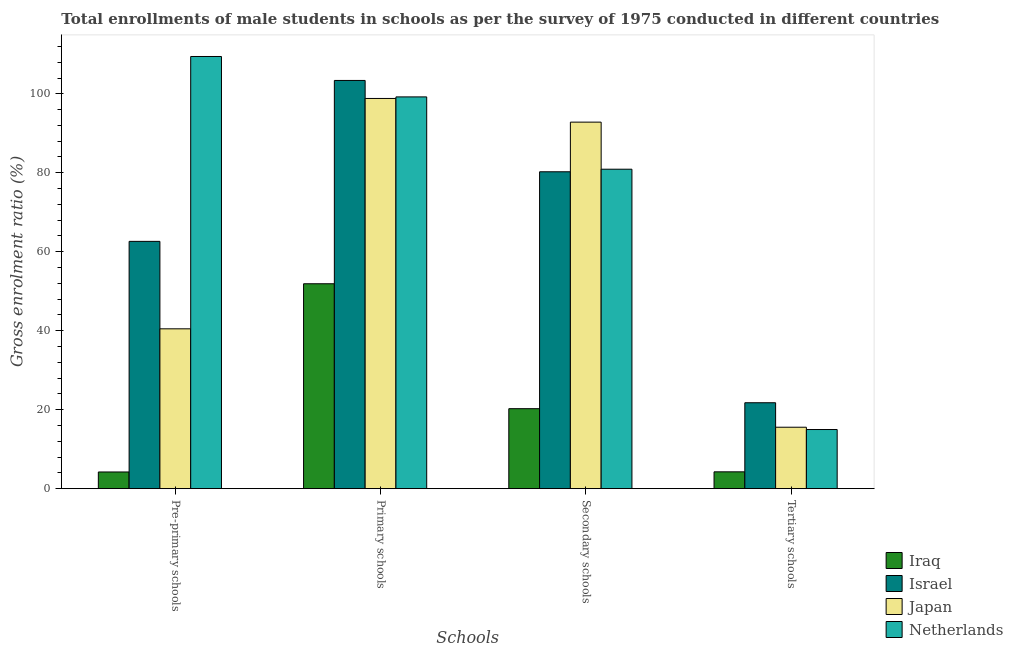Are the number of bars per tick equal to the number of legend labels?
Offer a terse response. Yes. Are the number of bars on each tick of the X-axis equal?
Offer a terse response. Yes. How many bars are there on the 2nd tick from the right?
Your response must be concise. 4. What is the label of the 2nd group of bars from the left?
Make the answer very short. Primary schools. What is the gross enrolment ratio(male) in tertiary schools in Israel?
Make the answer very short. 21.76. Across all countries, what is the maximum gross enrolment ratio(male) in pre-primary schools?
Your response must be concise. 109.46. Across all countries, what is the minimum gross enrolment ratio(male) in pre-primary schools?
Keep it short and to the point. 4.23. In which country was the gross enrolment ratio(male) in pre-primary schools minimum?
Keep it short and to the point. Iraq. What is the total gross enrolment ratio(male) in secondary schools in the graph?
Offer a very short reply. 274.25. What is the difference between the gross enrolment ratio(male) in secondary schools in Iraq and that in Israel?
Keep it short and to the point. -60. What is the difference between the gross enrolment ratio(male) in secondary schools in Israel and the gross enrolment ratio(male) in primary schools in Iraq?
Your answer should be very brief. 28.36. What is the average gross enrolment ratio(male) in tertiary schools per country?
Make the answer very short. 14.14. What is the difference between the gross enrolment ratio(male) in pre-primary schools and gross enrolment ratio(male) in tertiary schools in Israel?
Your response must be concise. 40.87. What is the ratio of the gross enrolment ratio(male) in tertiary schools in Japan to that in Iraq?
Your response must be concise. 3.65. Is the gross enrolment ratio(male) in secondary schools in Japan less than that in Netherlands?
Offer a very short reply. No. What is the difference between the highest and the second highest gross enrolment ratio(male) in pre-primary schools?
Provide a short and direct response. 46.82. What is the difference between the highest and the lowest gross enrolment ratio(male) in primary schools?
Offer a very short reply. 51.49. Is the sum of the gross enrolment ratio(male) in secondary schools in Netherlands and Iraq greater than the maximum gross enrolment ratio(male) in primary schools across all countries?
Your answer should be very brief. No. Where does the legend appear in the graph?
Offer a terse response. Bottom right. How are the legend labels stacked?
Offer a terse response. Vertical. What is the title of the graph?
Your answer should be very brief. Total enrollments of male students in schools as per the survey of 1975 conducted in different countries. What is the label or title of the X-axis?
Your answer should be very brief. Schools. What is the label or title of the Y-axis?
Offer a terse response. Gross enrolment ratio (%). What is the Gross enrolment ratio (%) of Iraq in Pre-primary schools?
Provide a short and direct response. 4.23. What is the Gross enrolment ratio (%) in Israel in Pre-primary schools?
Provide a succinct answer. 62.63. What is the Gross enrolment ratio (%) of Japan in Pre-primary schools?
Provide a succinct answer. 40.48. What is the Gross enrolment ratio (%) in Netherlands in Pre-primary schools?
Your answer should be very brief. 109.46. What is the Gross enrolment ratio (%) of Iraq in Primary schools?
Provide a succinct answer. 51.89. What is the Gross enrolment ratio (%) in Israel in Primary schools?
Make the answer very short. 103.39. What is the Gross enrolment ratio (%) in Japan in Primary schools?
Ensure brevity in your answer.  98.82. What is the Gross enrolment ratio (%) in Netherlands in Primary schools?
Your answer should be very brief. 99.22. What is the Gross enrolment ratio (%) of Iraq in Secondary schools?
Give a very brief answer. 20.26. What is the Gross enrolment ratio (%) of Israel in Secondary schools?
Ensure brevity in your answer.  80.26. What is the Gross enrolment ratio (%) of Japan in Secondary schools?
Offer a very short reply. 92.83. What is the Gross enrolment ratio (%) of Netherlands in Secondary schools?
Keep it short and to the point. 80.91. What is the Gross enrolment ratio (%) of Iraq in Tertiary schools?
Offer a terse response. 4.27. What is the Gross enrolment ratio (%) of Israel in Tertiary schools?
Make the answer very short. 21.76. What is the Gross enrolment ratio (%) of Japan in Tertiary schools?
Ensure brevity in your answer.  15.56. What is the Gross enrolment ratio (%) in Netherlands in Tertiary schools?
Make the answer very short. 14.98. Across all Schools, what is the maximum Gross enrolment ratio (%) in Iraq?
Your answer should be very brief. 51.89. Across all Schools, what is the maximum Gross enrolment ratio (%) in Israel?
Provide a succinct answer. 103.39. Across all Schools, what is the maximum Gross enrolment ratio (%) of Japan?
Provide a succinct answer. 98.82. Across all Schools, what is the maximum Gross enrolment ratio (%) of Netherlands?
Give a very brief answer. 109.46. Across all Schools, what is the minimum Gross enrolment ratio (%) of Iraq?
Provide a succinct answer. 4.23. Across all Schools, what is the minimum Gross enrolment ratio (%) of Israel?
Your response must be concise. 21.76. Across all Schools, what is the minimum Gross enrolment ratio (%) of Japan?
Offer a terse response. 15.56. Across all Schools, what is the minimum Gross enrolment ratio (%) in Netherlands?
Provide a short and direct response. 14.98. What is the total Gross enrolment ratio (%) in Iraq in the graph?
Make the answer very short. 80.65. What is the total Gross enrolment ratio (%) in Israel in the graph?
Your response must be concise. 268.04. What is the total Gross enrolment ratio (%) in Japan in the graph?
Make the answer very short. 247.7. What is the total Gross enrolment ratio (%) in Netherlands in the graph?
Make the answer very short. 304.56. What is the difference between the Gross enrolment ratio (%) of Iraq in Pre-primary schools and that in Primary schools?
Your answer should be very brief. -47.66. What is the difference between the Gross enrolment ratio (%) of Israel in Pre-primary schools and that in Primary schools?
Your response must be concise. -40.75. What is the difference between the Gross enrolment ratio (%) of Japan in Pre-primary schools and that in Primary schools?
Provide a succinct answer. -58.34. What is the difference between the Gross enrolment ratio (%) in Netherlands in Pre-primary schools and that in Primary schools?
Provide a succinct answer. 10.24. What is the difference between the Gross enrolment ratio (%) of Iraq in Pre-primary schools and that in Secondary schools?
Ensure brevity in your answer.  -16.03. What is the difference between the Gross enrolment ratio (%) in Israel in Pre-primary schools and that in Secondary schools?
Ensure brevity in your answer.  -17.62. What is the difference between the Gross enrolment ratio (%) in Japan in Pre-primary schools and that in Secondary schools?
Offer a very short reply. -52.34. What is the difference between the Gross enrolment ratio (%) in Netherlands in Pre-primary schools and that in Secondary schools?
Your answer should be compact. 28.55. What is the difference between the Gross enrolment ratio (%) in Iraq in Pre-primary schools and that in Tertiary schools?
Ensure brevity in your answer.  -0.04. What is the difference between the Gross enrolment ratio (%) in Israel in Pre-primary schools and that in Tertiary schools?
Offer a terse response. 40.87. What is the difference between the Gross enrolment ratio (%) of Japan in Pre-primary schools and that in Tertiary schools?
Offer a very short reply. 24.92. What is the difference between the Gross enrolment ratio (%) in Netherlands in Pre-primary schools and that in Tertiary schools?
Keep it short and to the point. 94.47. What is the difference between the Gross enrolment ratio (%) of Iraq in Primary schools and that in Secondary schools?
Provide a succinct answer. 31.64. What is the difference between the Gross enrolment ratio (%) in Israel in Primary schools and that in Secondary schools?
Give a very brief answer. 23.13. What is the difference between the Gross enrolment ratio (%) of Japan in Primary schools and that in Secondary schools?
Offer a terse response. 6. What is the difference between the Gross enrolment ratio (%) of Netherlands in Primary schools and that in Secondary schools?
Offer a very short reply. 18.31. What is the difference between the Gross enrolment ratio (%) in Iraq in Primary schools and that in Tertiary schools?
Your answer should be compact. 47.63. What is the difference between the Gross enrolment ratio (%) in Israel in Primary schools and that in Tertiary schools?
Your answer should be compact. 81.62. What is the difference between the Gross enrolment ratio (%) of Japan in Primary schools and that in Tertiary schools?
Make the answer very short. 83.26. What is the difference between the Gross enrolment ratio (%) of Netherlands in Primary schools and that in Tertiary schools?
Provide a succinct answer. 84.24. What is the difference between the Gross enrolment ratio (%) in Iraq in Secondary schools and that in Tertiary schools?
Offer a terse response. 15.99. What is the difference between the Gross enrolment ratio (%) of Israel in Secondary schools and that in Tertiary schools?
Provide a short and direct response. 58.49. What is the difference between the Gross enrolment ratio (%) in Japan in Secondary schools and that in Tertiary schools?
Your response must be concise. 77.26. What is the difference between the Gross enrolment ratio (%) of Netherlands in Secondary schools and that in Tertiary schools?
Your answer should be very brief. 65.92. What is the difference between the Gross enrolment ratio (%) in Iraq in Pre-primary schools and the Gross enrolment ratio (%) in Israel in Primary schools?
Provide a short and direct response. -99.16. What is the difference between the Gross enrolment ratio (%) of Iraq in Pre-primary schools and the Gross enrolment ratio (%) of Japan in Primary schools?
Provide a short and direct response. -94.59. What is the difference between the Gross enrolment ratio (%) in Iraq in Pre-primary schools and the Gross enrolment ratio (%) in Netherlands in Primary schools?
Provide a short and direct response. -94.99. What is the difference between the Gross enrolment ratio (%) in Israel in Pre-primary schools and the Gross enrolment ratio (%) in Japan in Primary schools?
Your response must be concise. -36.19. What is the difference between the Gross enrolment ratio (%) in Israel in Pre-primary schools and the Gross enrolment ratio (%) in Netherlands in Primary schools?
Your answer should be very brief. -36.59. What is the difference between the Gross enrolment ratio (%) of Japan in Pre-primary schools and the Gross enrolment ratio (%) of Netherlands in Primary schools?
Your answer should be very brief. -58.74. What is the difference between the Gross enrolment ratio (%) in Iraq in Pre-primary schools and the Gross enrolment ratio (%) in Israel in Secondary schools?
Make the answer very short. -76.03. What is the difference between the Gross enrolment ratio (%) in Iraq in Pre-primary schools and the Gross enrolment ratio (%) in Japan in Secondary schools?
Ensure brevity in your answer.  -88.6. What is the difference between the Gross enrolment ratio (%) in Iraq in Pre-primary schools and the Gross enrolment ratio (%) in Netherlands in Secondary schools?
Give a very brief answer. -76.68. What is the difference between the Gross enrolment ratio (%) of Israel in Pre-primary schools and the Gross enrolment ratio (%) of Japan in Secondary schools?
Make the answer very short. -30.19. What is the difference between the Gross enrolment ratio (%) in Israel in Pre-primary schools and the Gross enrolment ratio (%) in Netherlands in Secondary schools?
Make the answer very short. -18.27. What is the difference between the Gross enrolment ratio (%) in Japan in Pre-primary schools and the Gross enrolment ratio (%) in Netherlands in Secondary schools?
Provide a short and direct response. -40.42. What is the difference between the Gross enrolment ratio (%) in Iraq in Pre-primary schools and the Gross enrolment ratio (%) in Israel in Tertiary schools?
Your answer should be compact. -17.53. What is the difference between the Gross enrolment ratio (%) of Iraq in Pre-primary schools and the Gross enrolment ratio (%) of Japan in Tertiary schools?
Your answer should be compact. -11.33. What is the difference between the Gross enrolment ratio (%) of Iraq in Pre-primary schools and the Gross enrolment ratio (%) of Netherlands in Tertiary schools?
Your answer should be very brief. -10.75. What is the difference between the Gross enrolment ratio (%) of Israel in Pre-primary schools and the Gross enrolment ratio (%) of Japan in Tertiary schools?
Your answer should be compact. 47.07. What is the difference between the Gross enrolment ratio (%) in Israel in Pre-primary schools and the Gross enrolment ratio (%) in Netherlands in Tertiary schools?
Your answer should be compact. 47.65. What is the difference between the Gross enrolment ratio (%) of Japan in Pre-primary schools and the Gross enrolment ratio (%) of Netherlands in Tertiary schools?
Your answer should be very brief. 25.5. What is the difference between the Gross enrolment ratio (%) in Iraq in Primary schools and the Gross enrolment ratio (%) in Israel in Secondary schools?
Ensure brevity in your answer.  -28.36. What is the difference between the Gross enrolment ratio (%) in Iraq in Primary schools and the Gross enrolment ratio (%) in Japan in Secondary schools?
Keep it short and to the point. -40.93. What is the difference between the Gross enrolment ratio (%) of Iraq in Primary schools and the Gross enrolment ratio (%) of Netherlands in Secondary schools?
Offer a very short reply. -29.01. What is the difference between the Gross enrolment ratio (%) of Israel in Primary schools and the Gross enrolment ratio (%) of Japan in Secondary schools?
Keep it short and to the point. 10.56. What is the difference between the Gross enrolment ratio (%) of Israel in Primary schools and the Gross enrolment ratio (%) of Netherlands in Secondary schools?
Offer a terse response. 22.48. What is the difference between the Gross enrolment ratio (%) of Japan in Primary schools and the Gross enrolment ratio (%) of Netherlands in Secondary schools?
Your response must be concise. 17.92. What is the difference between the Gross enrolment ratio (%) of Iraq in Primary schools and the Gross enrolment ratio (%) of Israel in Tertiary schools?
Give a very brief answer. 30.13. What is the difference between the Gross enrolment ratio (%) of Iraq in Primary schools and the Gross enrolment ratio (%) of Japan in Tertiary schools?
Your answer should be very brief. 36.33. What is the difference between the Gross enrolment ratio (%) of Iraq in Primary schools and the Gross enrolment ratio (%) of Netherlands in Tertiary schools?
Keep it short and to the point. 36.91. What is the difference between the Gross enrolment ratio (%) in Israel in Primary schools and the Gross enrolment ratio (%) in Japan in Tertiary schools?
Offer a very short reply. 87.82. What is the difference between the Gross enrolment ratio (%) of Israel in Primary schools and the Gross enrolment ratio (%) of Netherlands in Tertiary schools?
Offer a very short reply. 88.41. What is the difference between the Gross enrolment ratio (%) of Japan in Primary schools and the Gross enrolment ratio (%) of Netherlands in Tertiary schools?
Your response must be concise. 83.84. What is the difference between the Gross enrolment ratio (%) in Iraq in Secondary schools and the Gross enrolment ratio (%) in Israel in Tertiary schools?
Your answer should be very brief. -1.5. What is the difference between the Gross enrolment ratio (%) of Iraq in Secondary schools and the Gross enrolment ratio (%) of Japan in Tertiary schools?
Give a very brief answer. 4.7. What is the difference between the Gross enrolment ratio (%) of Iraq in Secondary schools and the Gross enrolment ratio (%) of Netherlands in Tertiary schools?
Provide a short and direct response. 5.28. What is the difference between the Gross enrolment ratio (%) of Israel in Secondary schools and the Gross enrolment ratio (%) of Japan in Tertiary schools?
Offer a very short reply. 64.69. What is the difference between the Gross enrolment ratio (%) in Israel in Secondary schools and the Gross enrolment ratio (%) in Netherlands in Tertiary schools?
Offer a terse response. 65.28. What is the difference between the Gross enrolment ratio (%) in Japan in Secondary schools and the Gross enrolment ratio (%) in Netherlands in Tertiary schools?
Give a very brief answer. 77.85. What is the average Gross enrolment ratio (%) in Iraq per Schools?
Provide a short and direct response. 20.16. What is the average Gross enrolment ratio (%) of Israel per Schools?
Provide a succinct answer. 67.01. What is the average Gross enrolment ratio (%) in Japan per Schools?
Offer a terse response. 61.92. What is the average Gross enrolment ratio (%) of Netherlands per Schools?
Provide a short and direct response. 76.14. What is the difference between the Gross enrolment ratio (%) in Iraq and Gross enrolment ratio (%) in Israel in Pre-primary schools?
Your answer should be very brief. -58.4. What is the difference between the Gross enrolment ratio (%) in Iraq and Gross enrolment ratio (%) in Japan in Pre-primary schools?
Give a very brief answer. -36.25. What is the difference between the Gross enrolment ratio (%) in Iraq and Gross enrolment ratio (%) in Netherlands in Pre-primary schools?
Offer a very short reply. -105.22. What is the difference between the Gross enrolment ratio (%) of Israel and Gross enrolment ratio (%) of Japan in Pre-primary schools?
Give a very brief answer. 22.15. What is the difference between the Gross enrolment ratio (%) of Israel and Gross enrolment ratio (%) of Netherlands in Pre-primary schools?
Ensure brevity in your answer.  -46.82. What is the difference between the Gross enrolment ratio (%) of Japan and Gross enrolment ratio (%) of Netherlands in Pre-primary schools?
Keep it short and to the point. -68.97. What is the difference between the Gross enrolment ratio (%) of Iraq and Gross enrolment ratio (%) of Israel in Primary schools?
Ensure brevity in your answer.  -51.49. What is the difference between the Gross enrolment ratio (%) in Iraq and Gross enrolment ratio (%) in Japan in Primary schools?
Make the answer very short. -46.93. What is the difference between the Gross enrolment ratio (%) of Iraq and Gross enrolment ratio (%) of Netherlands in Primary schools?
Your answer should be compact. -47.32. What is the difference between the Gross enrolment ratio (%) of Israel and Gross enrolment ratio (%) of Japan in Primary schools?
Provide a short and direct response. 4.56. What is the difference between the Gross enrolment ratio (%) of Israel and Gross enrolment ratio (%) of Netherlands in Primary schools?
Make the answer very short. 4.17. What is the difference between the Gross enrolment ratio (%) of Japan and Gross enrolment ratio (%) of Netherlands in Primary schools?
Keep it short and to the point. -0.39. What is the difference between the Gross enrolment ratio (%) of Iraq and Gross enrolment ratio (%) of Israel in Secondary schools?
Ensure brevity in your answer.  -60. What is the difference between the Gross enrolment ratio (%) of Iraq and Gross enrolment ratio (%) of Japan in Secondary schools?
Ensure brevity in your answer.  -72.57. What is the difference between the Gross enrolment ratio (%) in Iraq and Gross enrolment ratio (%) in Netherlands in Secondary schools?
Offer a terse response. -60.65. What is the difference between the Gross enrolment ratio (%) of Israel and Gross enrolment ratio (%) of Japan in Secondary schools?
Ensure brevity in your answer.  -12.57. What is the difference between the Gross enrolment ratio (%) of Israel and Gross enrolment ratio (%) of Netherlands in Secondary schools?
Provide a succinct answer. -0.65. What is the difference between the Gross enrolment ratio (%) of Japan and Gross enrolment ratio (%) of Netherlands in Secondary schools?
Keep it short and to the point. 11.92. What is the difference between the Gross enrolment ratio (%) of Iraq and Gross enrolment ratio (%) of Israel in Tertiary schools?
Offer a terse response. -17.5. What is the difference between the Gross enrolment ratio (%) of Iraq and Gross enrolment ratio (%) of Japan in Tertiary schools?
Your answer should be very brief. -11.3. What is the difference between the Gross enrolment ratio (%) in Iraq and Gross enrolment ratio (%) in Netherlands in Tertiary schools?
Provide a short and direct response. -10.71. What is the difference between the Gross enrolment ratio (%) in Israel and Gross enrolment ratio (%) in Japan in Tertiary schools?
Keep it short and to the point. 6.2. What is the difference between the Gross enrolment ratio (%) of Israel and Gross enrolment ratio (%) of Netherlands in Tertiary schools?
Offer a terse response. 6.78. What is the difference between the Gross enrolment ratio (%) of Japan and Gross enrolment ratio (%) of Netherlands in Tertiary schools?
Your answer should be very brief. 0.58. What is the ratio of the Gross enrolment ratio (%) of Iraq in Pre-primary schools to that in Primary schools?
Make the answer very short. 0.08. What is the ratio of the Gross enrolment ratio (%) in Israel in Pre-primary schools to that in Primary schools?
Provide a short and direct response. 0.61. What is the ratio of the Gross enrolment ratio (%) in Japan in Pre-primary schools to that in Primary schools?
Your answer should be very brief. 0.41. What is the ratio of the Gross enrolment ratio (%) in Netherlands in Pre-primary schools to that in Primary schools?
Give a very brief answer. 1.1. What is the ratio of the Gross enrolment ratio (%) in Iraq in Pre-primary schools to that in Secondary schools?
Your answer should be very brief. 0.21. What is the ratio of the Gross enrolment ratio (%) in Israel in Pre-primary schools to that in Secondary schools?
Offer a very short reply. 0.78. What is the ratio of the Gross enrolment ratio (%) in Japan in Pre-primary schools to that in Secondary schools?
Give a very brief answer. 0.44. What is the ratio of the Gross enrolment ratio (%) in Netherlands in Pre-primary schools to that in Secondary schools?
Your answer should be compact. 1.35. What is the ratio of the Gross enrolment ratio (%) in Israel in Pre-primary schools to that in Tertiary schools?
Keep it short and to the point. 2.88. What is the ratio of the Gross enrolment ratio (%) in Japan in Pre-primary schools to that in Tertiary schools?
Your response must be concise. 2.6. What is the ratio of the Gross enrolment ratio (%) in Netherlands in Pre-primary schools to that in Tertiary schools?
Give a very brief answer. 7.31. What is the ratio of the Gross enrolment ratio (%) in Iraq in Primary schools to that in Secondary schools?
Your answer should be compact. 2.56. What is the ratio of the Gross enrolment ratio (%) of Israel in Primary schools to that in Secondary schools?
Give a very brief answer. 1.29. What is the ratio of the Gross enrolment ratio (%) of Japan in Primary schools to that in Secondary schools?
Your answer should be compact. 1.06. What is the ratio of the Gross enrolment ratio (%) of Netherlands in Primary schools to that in Secondary schools?
Provide a short and direct response. 1.23. What is the ratio of the Gross enrolment ratio (%) in Iraq in Primary schools to that in Tertiary schools?
Give a very brief answer. 12.16. What is the ratio of the Gross enrolment ratio (%) of Israel in Primary schools to that in Tertiary schools?
Your answer should be very brief. 4.75. What is the ratio of the Gross enrolment ratio (%) in Japan in Primary schools to that in Tertiary schools?
Provide a short and direct response. 6.35. What is the ratio of the Gross enrolment ratio (%) in Netherlands in Primary schools to that in Tertiary schools?
Give a very brief answer. 6.62. What is the ratio of the Gross enrolment ratio (%) of Iraq in Secondary schools to that in Tertiary schools?
Ensure brevity in your answer.  4.75. What is the ratio of the Gross enrolment ratio (%) of Israel in Secondary schools to that in Tertiary schools?
Give a very brief answer. 3.69. What is the ratio of the Gross enrolment ratio (%) in Japan in Secondary schools to that in Tertiary schools?
Provide a short and direct response. 5.96. What is the ratio of the Gross enrolment ratio (%) in Netherlands in Secondary schools to that in Tertiary schools?
Provide a succinct answer. 5.4. What is the difference between the highest and the second highest Gross enrolment ratio (%) in Iraq?
Offer a terse response. 31.64. What is the difference between the highest and the second highest Gross enrolment ratio (%) of Israel?
Your answer should be compact. 23.13. What is the difference between the highest and the second highest Gross enrolment ratio (%) of Japan?
Offer a terse response. 6. What is the difference between the highest and the second highest Gross enrolment ratio (%) in Netherlands?
Provide a succinct answer. 10.24. What is the difference between the highest and the lowest Gross enrolment ratio (%) in Iraq?
Provide a short and direct response. 47.66. What is the difference between the highest and the lowest Gross enrolment ratio (%) of Israel?
Your answer should be compact. 81.62. What is the difference between the highest and the lowest Gross enrolment ratio (%) of Japan?
Offer a terse response. 83.26. What is the difference between the highest and the lowest Gross enrolment ratio (%) of Netherlands?
Keep it short and to the point. 94.47. 